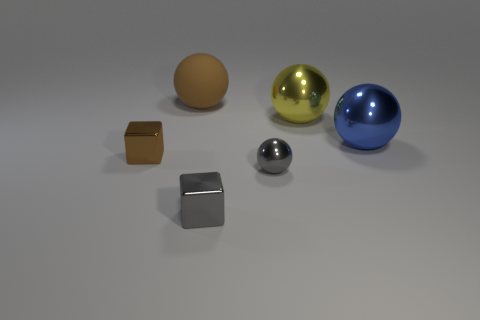Add 2 tiny green matte spheres. How many objects exist? 8 Subtract all red balls. Subtract all blue cubes. How many balls are left? 4 Subtract all balls. How many objects are left? 2 Subtract all large shiny things. Subtract all rubber balls. How many objects are left? 3 Add 5 gray metal balls. How many gray metal balls are left? 6 Add 3 big green rubber balls. How many big green rubber balls exist? 3 Subtract 0 purple cylinders. How many objects are left? 6 